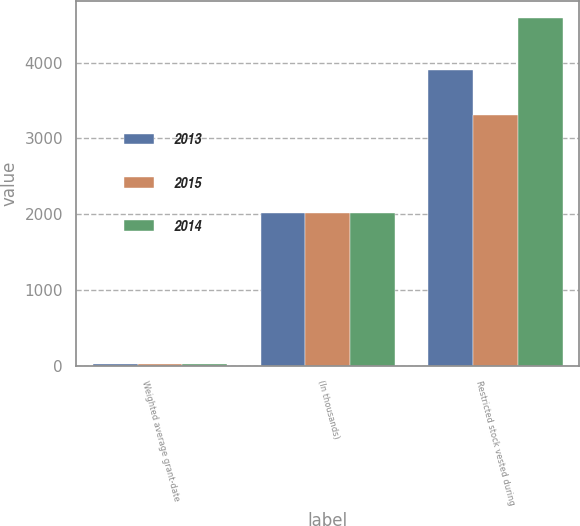Convert chart. <chart><loc_0><loc_0><loc_500><loc_500><stacked_bar_chart><ecel><fcel>Weighted average grant-date<fcel>(In thousands)<fcel>Restricted stock vested during<nl><fcel>2013<fcel>26.74<fcel>2015<fcel>3899<nl><fcel>2015<fcel>26.08<fcel>2014<fcel>3305<nl><fcel>2014<fcel>24.54<fcel>2013<fcel>4583<nl></chart> 